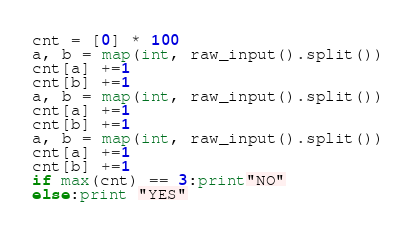Convert code to text. <code><loc_0><loc_0><loc_500><loc_500><_Python_>cnt = [0] * 100
a, b = map(int, raw_input().split())
cnt[a] +=1
cnt[b] +=1
a, b = map(int, raw_input().split())
cnt[a] +=1
cnt[b] +=1
a, b = map(int, raw_input().split())
cnt[a] +=1
cnt[b] +=1
if max(cnt) == 3:print"NO"
else:print "YES"
</code> 